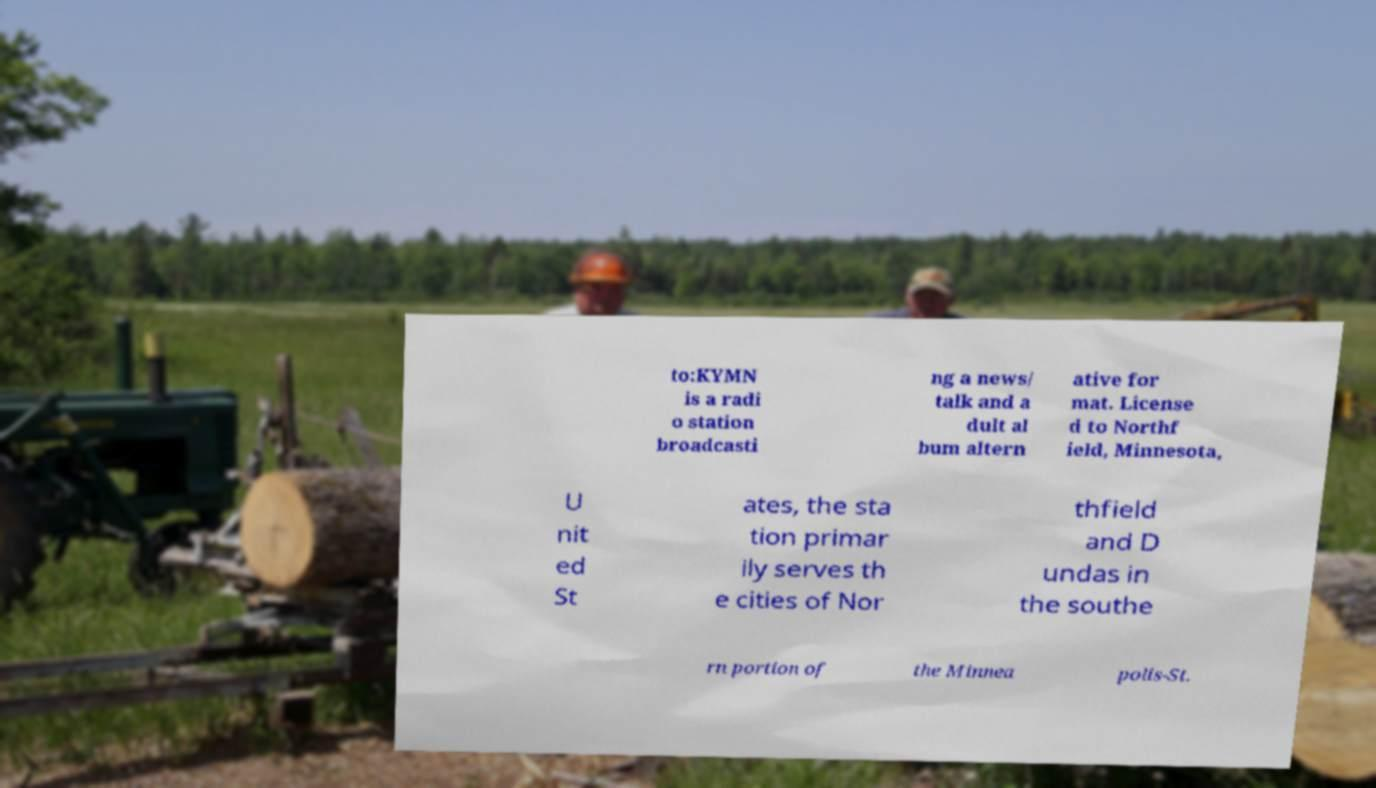Can you read and provide the text displayed in the image?This photo seems to have some interesting text. Can you extract and type it out for me? to:KYMN is a radi o station broadcasti ng a news/ talk and a dult al bum altern ative for mat. License d to Northf ield, Minnesota, U nit ed St ates, the sta tion primar ily serves th e cities of Nor thfield and D undas in the southe rn portion of the Minnea polis-St. 